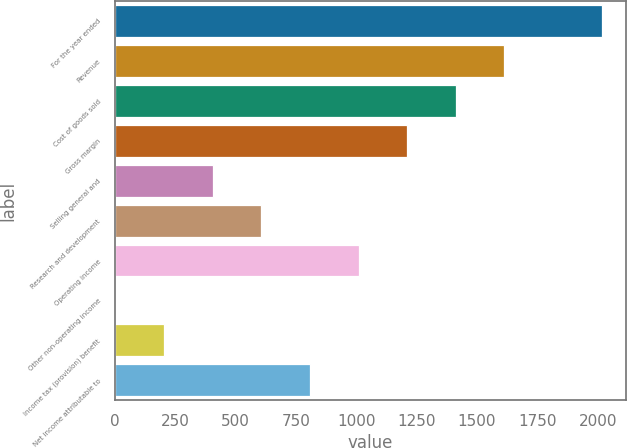Convert chart to OTSL. <chart><loc_0><loc_0><loc_500><loc_500><bar_chart><fcel>For the year ended<fcel>Revenue<fcel>Cost of goods sold<fcel>Gross margin<fcel>Selling general and<fcel>Research and development<fcel>Operating income<fcel>Other non-operating income<fcel>Income tax (provision) benefit<fcel>Net income attributable to<nl><fcel>2017<fcel>1613.8<fcel>1412.2<fcel>1210.6<fcel>404.2<fcel>605.8<fcel>1009<fcel>1<fcel>202.6<fcel>807.4<nl></chart> 